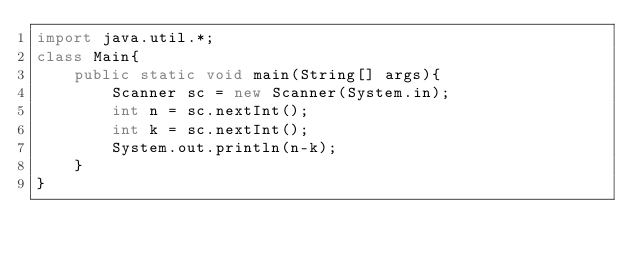<code> <loc_0><loc_0><loc_500><loc_500><_Java_>import java.util.*;
class Main{
    public static void main(String[] args){
        Scanner sc = new Scanner(System.in);
        int n = sc.nextInt();
        int k = sc.nextInt();
        System.out.println(n-k);
    }
}
</code> 